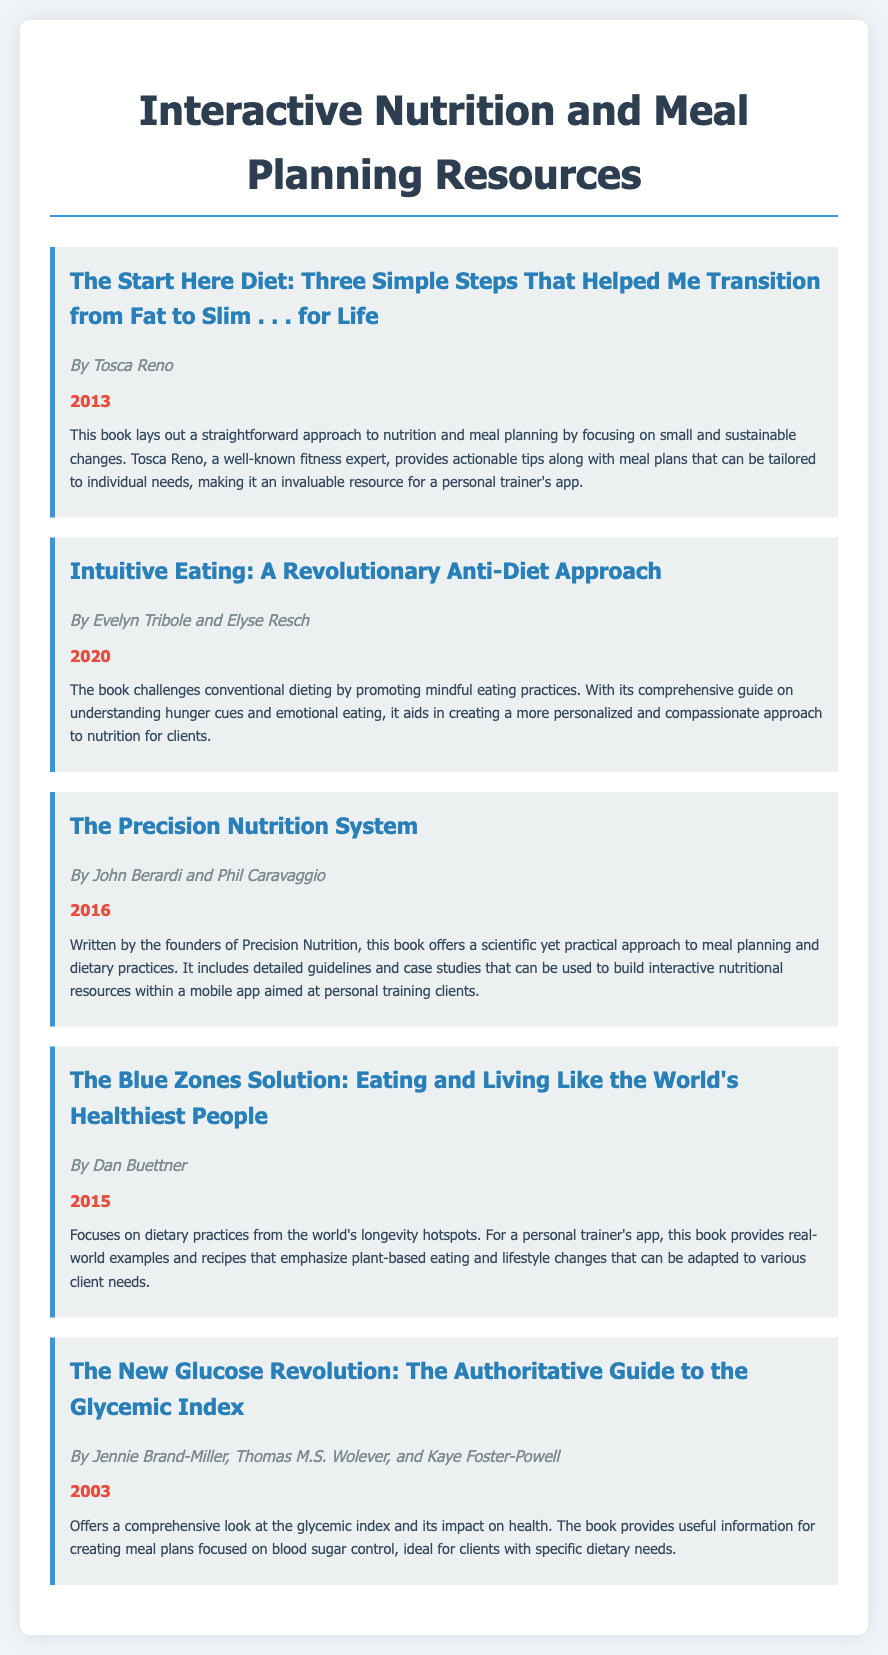What is the title of the first book listed? The first book listed is identified in the document by its title, "The Start Here Diet: Three Simple Steps That Helped Me Transition from Fat to Slim . . . for Life."
Answer: The Start Here Diet: Three Simple Steps That Helped Me Transition from Fat to Slim . . . for Life Who is the author of "Intuitive Eating"? The document specifies that "Intuitive Eating" is authored by Evelyn Tribole and Elyse Resch.
Answer: Evelyn Tribole and Elyse Resch What year was "The Precision Nutrition System" published? The document includes the publication year of "The Precision Nutrition System," which is mentioned as 2016.
Answer: 2016 Which book focuses on the glycemic index? The title of the book that focuses on the glycemic index is provided in the document as "The New Glucose Revolution: The Authoritative Guide to the Glycemic Index."
Answer: The New Glucose Revolution: The Authoritative Guide to the Glycemic Index How many books are listed in the bibliography? The document contains five distinct book entries, each providing relevant nutritional information.
Answer: Five What is a key theme of "The Blue Zones Solution"? The document summarizes a key theme of "The Blue Zones Solution" as focusing on dietary practices from longevity hotspots, emphasizing plant-based eating.
Answer: Dietary practices from longevity hotspots What type of approach does "Intuitive Eating" promote? The document explains that "Intuitive Eating" promotes an anti-diet approach, focusing on mindful eating practices.
Answer: Anti-diet approach According to "The Start Here Diet," what is emphasized for meal planning? The emphasis in "The Start Here Diet," as summarized in the document, is on small and sustainable changes relating to nutrition and meal planning.
Answer: Small and sustainable changes What is the central focus of "The New Glucose Revolution"? The document indicates that "The New Glucose Revolution" focuses on the glycemic index and its health impacts.
Answer: Glycemic index 